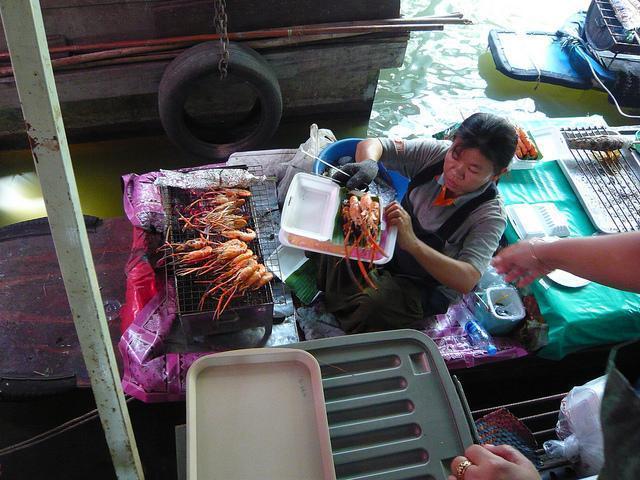What is this person's profession?
Answer the question by selecting the correct answer among the 4 following choices.
Options: Singer, dancer, lawyer, fisherman. Fisherman. 